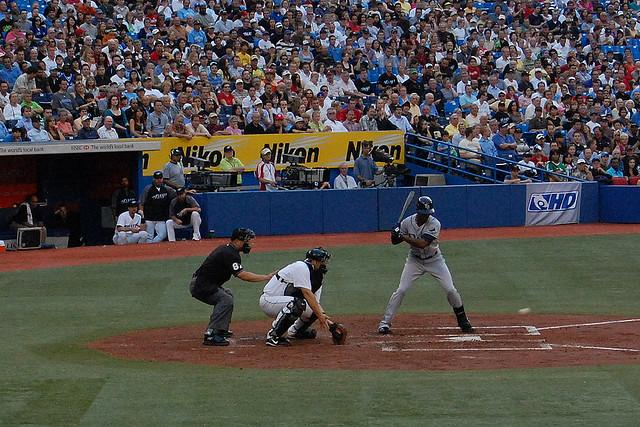What kind of product does the sponsor with the yellow background offer? Please explain your reasoning. cameras. The sponsor with the yellow background is nikon. this company does not make musical instruments, phones, or computers. 